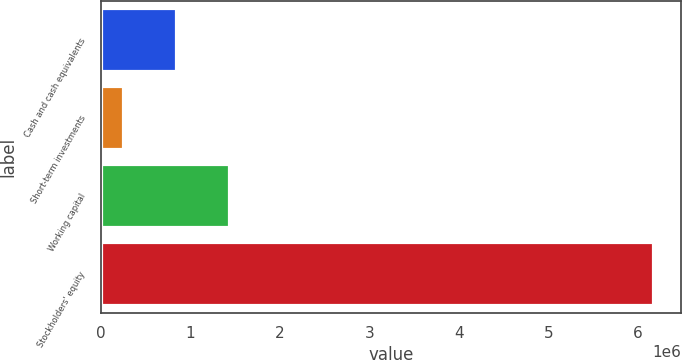<chart> <loc_0><loc_0><loc_500><loc_500><bar_chart><fcel>Cash and cash equivalents<fcel>Short-term investments<fcel>Working capital<fcel>Stockholders' equity<nl><fcel>837663<fcel>244830<fcel>1.4305e+06<fcel>6.17316e+06<nl></chart> 